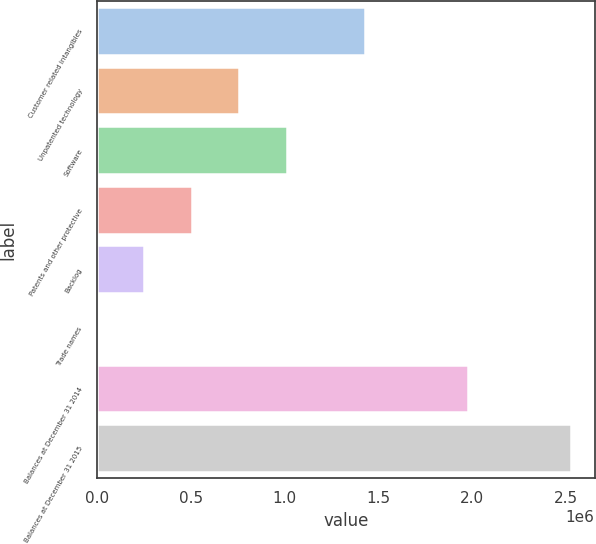<chart> <loc_0><loc_0><loc_500><loc_500><bar_chart><fcel>Customer related intangibles<fcel>Unpatented technology<fcel>Software<fcel>Patents and other protective<fcel>Backlog<fcel>Trade names<fcel>Balances at December 31 2014<fcel>Balances at December 31 2015<nl><fcel>1.43174e+06<fcel>759084<fcel>1.01193e+06<fcel>506239<fcel>253395<fcel>550<fcel>1.97873e+06<fcel>2.529e+06<nl></chart> 